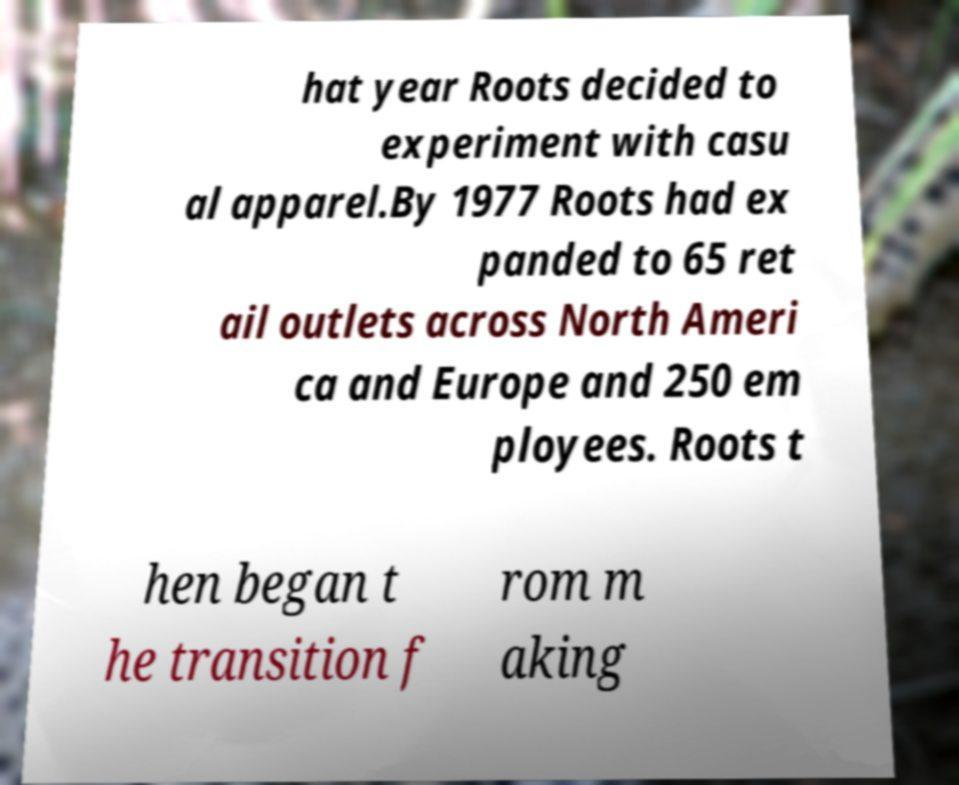Please read and relay the text visible in this image. What does it say? hat year Roots decided to experiment with casu al apparel.By 1977 Roots had ex panded to 65 ret ail outlets across North Ameri ca and Europe and 250 em ployees. Roots t hen began t he transition f rom m aking 